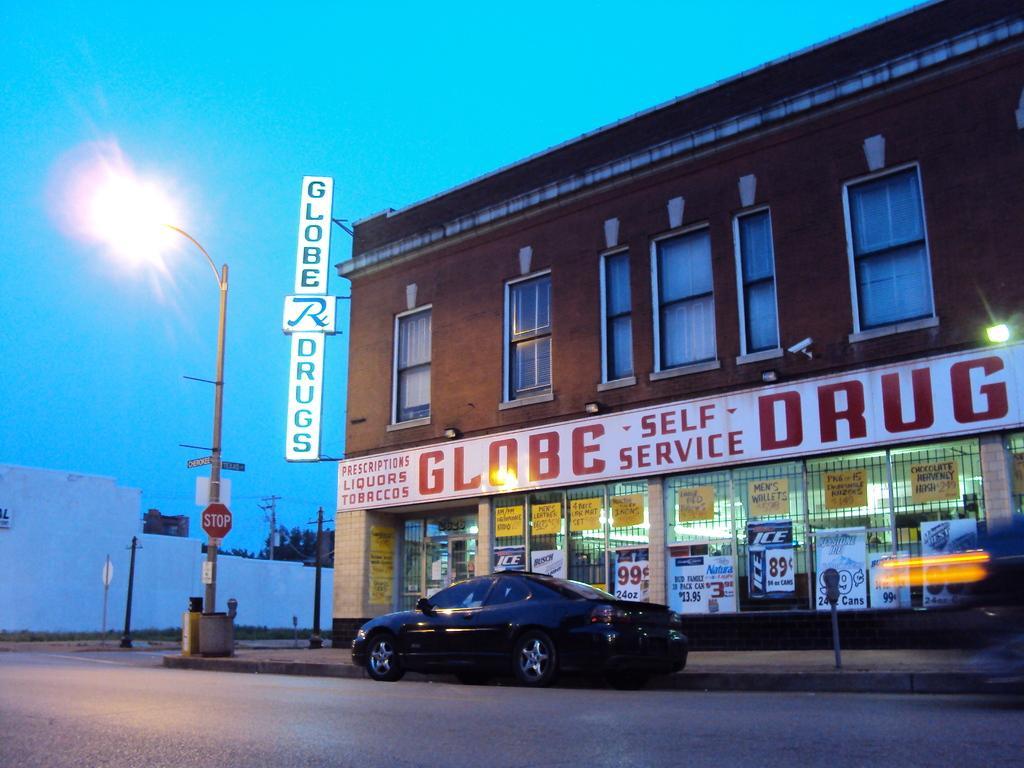Please provide a concise description of this image. In this image, we can see a car on the road and in the background, there is a building, poles, lights and there is a name board. 